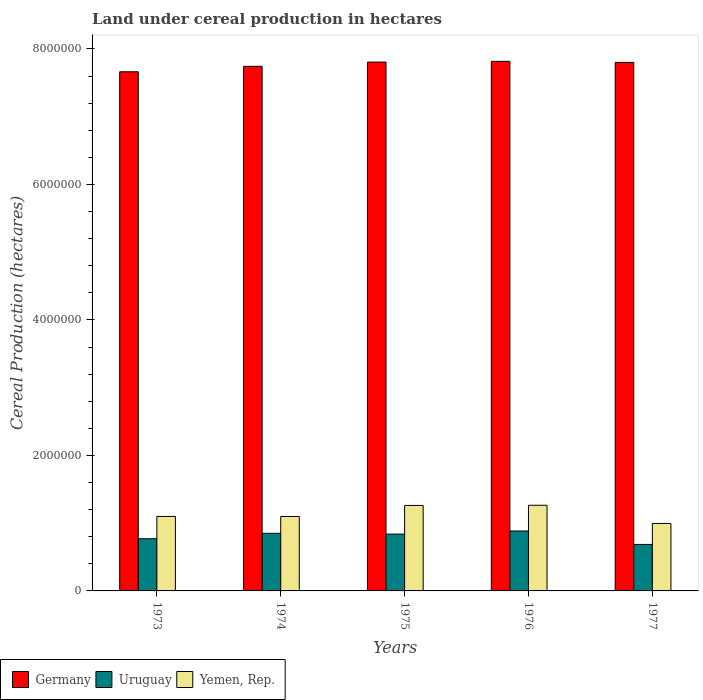How many different coloured bars are there?
Give a very brief answer. 3. Are the number of bars per tick equal to the number of legend labels?
Offer a terse response. Yes. Are the number of bars on each tick of the X-axis equal?
Provide a short and direct response. Yes. How many bars are there on the 4th tick from the left?
Offer a terse response. 3. What is the land under cereal production in Germany in 1974?
Provide a succinct answer. 7.74e+06. Across all years, what is the maximum land under cereal production in Yemen, Rep.?
Give a very brief answer. 1.26e+06. Across all years, what is the minimum land under cereal production in Uruguay?
Provide a short and direct response. 6.86e+05. In which year was the land under cereal production in Yemen, Rep. maximum?
Make the answer very short. 1976. What is the total land under cereal production in Germany in the graph?
Your answer should be very brief. 3.88e+07. What is the difference between the land under cereal production in Germany in 1973 and that in 1977?
Your answer should be compact. -1.38e+05. What is the difference between the land under cereal production in Yemen, Rep. in 1973 and the land under cereal production in Germany in 1974?
Provide a succinct answer. -6.64e+06. What is the average land under cereal production in Uruguay per year?
Offer a very short reply. 8.06e+05. In the year 1975, what is the difference between the land under cereal production in Yemen, Rep. and land under cereal production in Uruguay?
Make the answer very short. 4.23e+05. What is the ratio of the land under cereal production in Yemen, Rep. in 1974 to that in 1976?
Your response must be concise. 0.87. What is the difference between the highest and the second highest land under cereal production in Germany?
Your answer should be compact. 1.08e+04. What is the difference between the highest and the lowest land under cereal production in Yemen, Rep.?
Keep it short and to the point. 2.69e+05. In how many years, is the land under cereal production in Yemen, Rep. greater than the average land under cereal production in Yemen, Rep. taken over all years?
Make the answer very short. 2. Is the sum of the land under cereal production in Yemen, Rep. in 1975 and 1977 greater than the maximum land under cereal production in Germany across all years?
Provide a succinct answer. No. What does the 3rd bar from the left in 1976 represents?
Offer a terse response. Yemen, Rep. What does the 1st bar from the right in 1976 represents?
Keep it short and to the point. Yemen, Rep. Is it the case that in every year, the sum of the land under cereal production in Uruguay and land under cereal production in Yemen, Rep. is greater than the land under cereal production in Germany?
Offer a terse response. No. Are all the bars in the graph horizontal?
Your answer should be compact. No. How many years are there in the graph?
Offer a terse response. 5. What is the difference between two consecutive major ticks on the Y-axis?
Offer a very short reply. 2.00e+06. Are the values on the major ticks of Y-axis written in scientific E-notation?
Keep it short and to the point. No. What is the title of the graph?
Ensure brevity in your answer.  Land under cereal production in hectares. Does "Slovenia" appear as one of the legend labels in the graph?
Keep it short and to the point. No. What is the label or title of the Y-axis?
Your response must be concise. Cereal Production (hectares). What is the Cereal Production (hectares) in Germany in 1973?
Provide a succinct answer. 7.66e+06. What is the Cereal Production (hectares) in Uruguay in 1973?
Provide a short and direct response. 7.70e+05. What is the Cereal Production (hectares) in Yemen, Rep. in 1973?
Offer a very short reply. 1.10e+06. What is the Cereal Production (hectares) in Germany in 1974?
Offer a very short reply. 7.74e+06. What is the Cereal Production (hectares) of Uruguay in 1974?
Offer a very short reply. 8.50e+05. What is the Cereal Production (hectares) in Yemen, Rep. in 1974?
Provide a succinct answer. 1.10e+06. What is the Cereal Production (hectares) of Germany in 1975?
Offer a terse response. 7.81e+06. What is the Cereal Production (hectares) of Uruguay in 1975?
Your response must be concise. 8.39e+05. What is the Cereal Production (hectares) in Yemen, Rep. in 1975?
Your response must be concise. 1.26e+06. What is the Cereal Production (hectares) in Germany in 1976?
Make the answer very short. 7.82e+06. What is the Cereal Production (hectares) of Uruguay in 1976?
Keep it short and to the point. 8.84e+05. What is the Cereal Production (hectares) in Yemen, Rep. in 1976?
Make the answer very short. 1.26e+06. What is the Cereal Production (hectares) of Germany in 1977?
Your answer should be compact. 7.80e+06. What is the Cereal Production (hectares) in Uruguay in 1977?
Make the answer very short. 6.86e+05. What is the Cereal Production (hectares) of Yemen, Rep. in 1977?
Make the answer very short. 9.96e+05. Across all years, what is the maximum Cereal Production (hectares) in Germany?
Give a very brief answer. 7.82e+06. Across all years, what is the maximum Cereal Production (hectares) of Uruguay?
Your answer should be very brief. 8.84e+05. Across all years, what is the maximum Cereal Production (hectares) of Yemen, Rep.?
Make the answer very short. 1.26e+06. Across all years, what is the minimum Cereal Production (hectares) of Germany?
Your answer should be very brief. 7.66e+06. Across all years, what is the minimum Cereal Production (hectares) in Uruguay?
Offer a terse response. 6.86e+05. Across all years, what is the minimum Cereal Production (hectares) in Yemen, Rep.?
Make the answer very short. 9.96e+05. What is the total Cereal Production (hectares) in Germany in the graph?
Provide a succinct answer. 3.88e+07. What is the total Cereal Production (hectares) of Uruguay in the graph?
Keep it short and to the point. 4.03e+06. What is the total Cereal Production (hectares) in Yemen, Rep. in the graph?
Offer a very short reply. 5.72e+06. What is the difference between the Cereal Production (hectares) in Germany in 1973 and that in 1974?
Your response must be concise. -8.06e+04. What is the difference between the Cereal Production (hectares) of Uruguay in 1973 and that in 1974?
Provide a succinct answer. -8.00e+04. What is the difference between the Cereal Production (hectares) of Yemen, Rep. in 1973 and that in 1974?
Your response must be concise. 1048. What is the difference between the Cereal Production (hectares) of Germany in 1973 and that in 1975?
Your response must be concise. -1.43e+05. What is the difference between the Cereal Production (hectares) of Uruguay in 1973 and that in 1975?
Your answer should be very brief. -6.84e+04. What is the difference between the Cereal Production (hectares) in Yemen, Rep. in 1973 and that in 1975?
Ensure brevity in your answer.  -1.62e+05. What is the difference between the Cereal Production (hectares) in Germany in 1973 and that in 1976?
Your answer should be compact. -1.54e+05. What is the difference between the Cereal Production (hectares) in Uruguay in 1973 and that in 1976?
Provide a succinct answer. -1.14e+05. What is the difference between the Cereal Production (hectares) of Yemen, Rep. in 1973 and that in 1976?
Offer a terse response. -1.65e+05. What is the difference between the Cereal Production (hectares) in Germany in 1973 and that in 1977?
Ensure brevity in your answer.  -1.38e+05. What is the difference between the Cereal Production (hectares) in Uruguay in 1973 and that in 1977?
Give a very brief answer. 8.44e+04. What is the difference between the Cereal Production (hectares) of Yemen, Rep. in 1973 and that in 1977?
Offer a terse response. 1.04e+05. What is the difference between the Cereal Production (hectares) of Germany in 1974 and that in 1975?
Your answer should be compact. -6.24e+04. What is the difference between the Cereal Production (hectares) in Uruguay in 1974 and that in 1975?
Ensure brevity in your answer.  1.16e+04. What is the difference between the Cereal Production (hectares) of Yemen, Rep. in 1974 and that in 1975?
Offer a terse response. -1.63e+05. What is the difference between the Cereal Production (hectares) in Germany in 1974 and that in 1976?
Your answer should be compact. -7.32e+04. What is the difference between the Cereal Production (hectares) in Uruguay in 1974 and that in 1976?
Your response must be concise. -3.38e+04. What is the difference between the Cereal Production (hectares) of Yemen, Rep. in 1974 and that in 1976?
Offer a terse response. -1.66e+05. What is the difference between the Cereal Production (hectares) of Germany in 1974 and that in 1977?
Give a very brief answer. -5.75e+04. What is the difference between the Cereal Production (hectares) of Uruguay in 1974 and that in 1977?
Offer a terse response. 1.64e+05. What is the difference between the Cereal Production (hectares) in Yemen, Rep. in 1974 and that in 1977?
Give a very brief answer. 1.03e+05. What is the difference between the Cereal Production (hectares) in Germany in 1975 and that in 1976?
Ensure brevity in your answer.  -1.08e+04. What is the difference between the Cereal Production (hectares) of Uruguay in 1975 and that in 1976?
Provide a short and direct response. -4.54e+04. What is the difference between the Cereal Production (hectares) of Yemen, Rep. in 1975 and that in 1976?
Provide a short and direct response. -2667. What is the difference between the Cereal Production (hectares) in Germany in 1975 and that in 1977?
Give a very brief answer. 4952. What is the difference between the Cereal Production (hectares) in Uruguay in 1975 and that in 1977?
Make the answer very short. 1.53e+05. What is the difference between the Cereal Production (hectares) in Yemen, Rep. in 1975 and that in 1977?
Your response must be concise. 2.66e+05. What is the difference between the Cereal Production (hectares) of Germany in 1976 and that in 1977?
Make the answer very short. 1.58e+04. What is the difference between the Cereal Production (hectares) in Uruguay in 1976 and that in 1977?
Give a very brief answer. 1.98e+05. What is the difference between the Cereal Production (hectares) in Yemen, Rep. in 1976 and that in 1977?
Offer a terse response. 2.69e+05. What is the difference between the Cereal Production (hectares) of Germany in 1973 and the Cereal Production (hectares) of Uruguay in 1974?
Give a very brief answer. 6.81e+06. What is the difference between the Cereal Production (hectares) of Germany in 1973 and the Cereal Production (hectares) of Yemen, Rep. in 1974?
Your answer should be very brief. 6.56e+06. What is the difference between the Cereal Production (hectares) of Uruguay in 1973 and the Cereal Production (hectares) of Yemen, Rep. in 1974?
Your response must be concise. -3.28e+05. What is the difference between the Cereal Production (hectares) in Germany in 1973 and the Cereal Production (hectares) in Uruguay in 1975?
Give a very brief answer. 6.82e+06. What is the difference between the Cereal Production (hectares) in Germany in 1973 and the Cereal Production (hectares) in Yemen, Rep. in 1975?
Provide a succinct answer. 6.40e+06. What is the difference between the Cereal Production (hectares) of Uruguay in 1973 and the Cereal Production (hectares) of Yemen, Rep. in 1975?
Your response must be concise. -4.91e+05. What is the difference between the Cereal Production (hectares) in Germany in 1973 and the Cereal Production (hectares) in Uruguay in 1976?
Offer a very short reply. 6.78e+06. What is the difference between the Cereal Production (hectares) of Germany in 1973 and the Cereal Production (hectares) of Yemen, Rep. in 1976?
Provide a short and direct response. 6.40e+06. What is the difference between the Cereal Production (hectares) of Uruguay in 1973 and the Cereal Production (hectares) of Yemen, Rep. in 1976?
Give a very brief answer. -4.94e+05. What is the difference between the Cereal Production (hectares) of Germany in 1973 and the Cereal Production (hectares) of Uruguay in 1977?
Your response must be concise. 6.98e+06. What is the difference between the Cereal Production (hectares) in Germany in 1973 and the Cereal Production (hectares) in Yemen, Rep. in 1977?
Give a very brief answer. 6.67e+06. What is the difference between the Cereal Production (hectares) of Uruguay in 1973 and the Cereal Production (hectares) of Yemen, Rep. in 1977?
Give a very brief answer. -2.25e+05. What is the difference between the Cereal Production (hectares) of Germany in 1974 and the Cereal Production (hectares) of Uruguay in 1975?
Your response must be concise. 6.90e+06. What is the difference between the Cereal Production (hectares) in Germany in 1974 and the Cereal Production (hectares) in Yemen, Rep. in 1975?
Ensure brevity in your answer.  6.48e+06. What is the difference between the Cereal Production (hectares) in Uruguay in 1974 and the Cereal Production (hectares) in Yemen, Rep. in 1975?
Your answer should be very brief. -4.11e+05. What is the difference between the Cereal Production (hectares) in Germany in 1974 and the Cereal Production (hectares) in Uruguay in 1976?
Keep it short and to the point. 6.86e+06. What is the difference between the Cereal Production (hectares) of Germany in 1974 and the Cereal Production (hectares) of Yemen, Rep. in 1976?
Your response must be concise. 6.48e+06. What is the difference between the Cereal Production (hectares) of Uruguay in 1974 and the Cereal Production (hectares) of Yemen, Rep. in 1976?
Give a very brief answer. -4.14e+05. What is the difference between the Cereal Production (hectares) of Germany in 1974 and the Cereal Production (hectares) of Uruguay in 1977?
Your answer should be very brief. 7.06e+06. What is the difference between the Cereal Production (hectares) of Germany in 1974 and the Cereal Production (hectares) of Yemen, Rep. in 1977?
Give a very brief answer. 6.75e+06. What is the difference between the Cereal Production (hectares) of Uruguay in 1974 and the Cereal Production (hectares) of Yemen, Rep. in 1977?
Your answer should be very brief. -1.45e+05. What is the difference between the Cereal Production (hectares) in Germany in 1975 and the Cereal Production (hectares) in Uruguay in 1976?
Your response must be concise. 6.92e+06. What is the difference between the Cereal Production (hectares) in Germany in 1975 and the Cereal Production (hectares) in Yemen, Rep. in 1976?
Provide a succinct answer. 6.54e+06. What is the difference between the Cereal Production (hectares) of Uruguay in 1975 and the Cereal Production (hectares) of Yemen, Rep. in 1976?
Your answer should be very brief. -4.26e+05. What is the difference between the Cereal Production (hectares) in Germany in 1975 and the Cereal Production (hectares) in Uruguay in 1977?
Provide a short and direct response. 7.12e+06. What is the difference between the Cereal Production (hectares) in Germany in 1975 and the Cereal Production (hectares) in Yemen, Rep. in 1977?
Your answer should be very brief. 6.81e+06. What is the difference between the Cereal Production (hectares) in Uruguay in 1975 and the Cereal Production (hectares) in Yemen, Rep. in 1977?
Offer a terse response. -1.57e+05. What is the difference between the Cereal Production (hectares) of Germany in 1976 and the Cereal Production (hectares) of Uruguay in 1977?
Your answer should be very brief. 7.13e+06. What is the difference between the Cereal Production (hectares) of Germany in 1976 and the Cereal Production (hectares) of Yemen, Rep. in 1977?
Your response must be concise. 6.82e+06. What is the difference between the Cereal Production (hectares) of Uruguay in 1976 and the Cereal Production (hectares) of Yemen, Rep. in 1977?
Your response must be concise. -1.11e+05. What is the average Cereal Production (hectares) in Germany per year?
Keep it short and to the point. 7.77e+06. What is the average Cereal Production (hectares) of Uruguay per year?
Your answer should be very brief. 8.06e+05. What is the average Cereal Production (hectares) in Yemen, Rep. per year?
Your answer should be compact. 1.14e+06. In the year 1973, what is the difference between the Cereal Production (hectares) of Germany and Cereal Production (hectares) of Uruguay?
Your answer should be very brief. 6.89e+06. In the year 1973, what is the difference between the Cereal Production (hectares) in Germany and Cereal Production (hectares) in Yemen, Rep.?
Offer a terse response. 6.56e+06. In the year 1973, what is the difference between the Cereal Production (hectares) of Uruguay and Cereal Production (hectares) of Yemen, Rep.?
Provide a succinct answer. -3.29e+05. In the year 1974, what is the difference between the Cereal Production (hectares) in Germany and Cereal Production (hectares) in Uruguay?
Your response must be concise. 6.89e+06. In the year 1974, what is the difference between the Cereal Production (hectares) in Germany and Cereal Production (hectares) in Yemen, Rep.?
Your answer should be very brief. 6.64e+06. In the year 1974, what is the difference between the Cereal Production (hectares) of Uruguay and Cereal Production (hectares) of Yemen, Rep.?
Provide a short and direct response. -2.48e+05. In the year 1975, what is the difference between the Cereal Production (hectares) of Germany and Cereal Production (hectares) of Uruguay?
Offer a very short reply. 6.97e+06. In the year 1975, what is the difference between the Cereal Production (hectares) in Germany and Cereal Production (hectares) in Yemen, Rep.?
Your answer should be very brief. 6.54e+06. In the year 1975, what is the difference between the Cereal Production (hectares) of Uruguay and Cereal Production (hectares) of Yemen, Rep.?
Ensure brevity in your answer.  -4.23e+05. In the year 1976, what is the difference between the Cereal Production (hectares) of Germany and Cereal Production (hectares) of Uruguay?
Ensure brevity in your answer.  6.93e+06. In the year 1976, what is the difference between the Cereal Production (hectares) of Germany and Cereal Production (hectares) of Yemen, Rep.?
Ensure brevity in your answer.  6.55e+06. In the year 1976, what is the difference between the Cereal Production (hectares) of Uruguay and Cereal Production (hectares) of Yemen, Rep.?
Your answer should be very brief. -3.80e+05. In the year 1977, what is the difference between the Cereal Production (hectares) of Germany and Cereal Production (hectares) of Uruguay?
Keep it short and to the point. 7.11e+06. In the year 1977, what is the difference between the Cereal Production (hectares) of Germany and Cereal Production (hectares) of Yemen, Rep.?
Provide a succinct answer. 6.80e+06. In the year 1977, what is the difference between the Cereal Production (hectares) in Uruguay and Cereal Production (hectares) in Yemen, Rep.?
Offer a terse response. -3.10e+05. What is the ratio of the Cereal Production (hectares) of Uruguay in 1973 to that in 1974?
Offer a terse response. 0.91. What is the ratio of the Cereal Production (hectares) of Germany in 1973 to that in 1975?
Ensure brevity in your answer.  0.98. What is the ratio of the Cereal Production (hectares) of Uruguay in 1973 to that in 1975?
Ensure brevity in your answer.  0.92. What is the ratio of the Cereal Production (hectares) in Yemen, Rep. in 1973 to that in 1975?
Give a very brief answer. 0.87. What is the ratio of the Cereal Production (hectares) of Germany in 1973 to that in 1976?
Provide a short and direct response. 0.98. What is the ratio of the Cereal Production (hectares) in Uruguay in 1973 to that in 1976?
Ensure brevity in your answer.  0.87. What is the ratio of the Cereal Production (hectares) in Yemen, Rep. in 1973 to that in 1976?
Offer a terse response. 0.87. What is the ratio of the Cereal Production (hectares) of Germany in 1973 to that in 1977?
Keep it short and to the point. 0.98. What is the ratio of the Cereal Production (hectares) of Uruguay in 1973 to that in 1977?
Offer a very short reply. 1.12. What is the ratio of the Cereal Production (hectares) in Yemen, Rep. in 1973 to that in 1977?
Your answer should be compact. 1.1. What is the ratio of the Cereal Production (hectares) in Germany in 1974 to that in 1975?
Your answer should be very brief. 0.99. What is the ratio of the Cereal Production (hectares) of Uruguay in 1974 to that in 1975?
Make the answer very short. 1.01. What is the ratio of the Cereal Production (hectares) in Yemen, Rep. in 1974 to that in 1975?
Your answer should be very brief. 0.87. What is the ratio of the Cereal Production (hectares) of Germany in 1974 to that in 1976?
Your response must be concise. 0.99. What is the ratio of the Cereal Production (hectares) of Uruguay in 1974 to that in 1976?
Provide a succinct answer. 0.96. What is the ratio of the Cereal Production (hectares) of Yemen, Rep. in 1974 to that in 1976?
Offer a terse response. 0.87. What is the ratio of the Cereal Production (hectares) in Uruguay in 1974 to that in 1977?
Ensure brevity in your answer.  1.24. What is the ratio of the Cereal Production (hectares) of Yemen, Rep. in 1974 to that in 1977?
Ensure brevity in your answer.  1.1. What is the ratio of the Cereal Production (hectares) in Uruguay in 1975 to that in 1976?
Provide a short and direct response. 0.95. What is the ratio of the Cereal Production (hectares) in Yemen, Rep. in 1975 to that in 1976?
Give a very brief answer. 1. What is the ratio of the Cereal Production (hectares) in Uruguay in 1975 to that in 1977?
Provide a short and direct response. 1.22. What is the ratio of the Cereal Production (hectares) of Yemen, Rep. in 1975 to that in 1977?
Your response must be concise. 1.27. What is the ratio of the Cereal Production (hectares) of Germany in 1976 to that in 1977?
Provide a succinct answer. 1. What is the ratio of the Cereal Production (hectares) in Uruguay in 1976 to that in 1977?
Your answer should be compact. 1.29. What is the ratio of the Cereal Production (hectares) of Yemen, Rep. in 1976 to that in 1977?
Offer a very short reply. 1.27. What is the difference between the highest and the second highest Cereal Production (hectares) in Germany?
Offer a very short reply. 1.08e+04. What is the difference between the highest and the second highest Cereal Production (hectares) in Uruguay?
Ensure brevity in your answer.  3.38e+04. What is the difference between the highest and the second highest Cereal Production (hectares) of Yemen, Rep.?
Keep it short and to the point. 2667. What is the difference between the highest and the lowest Cereal Production (hectares) of Germany?
Provide a short and direct response. 1.54e+05. What is the difference between the highest and the lowest Cereal Production (hectares) in Uruguay?
Your answer should be very brief. 1.98e+05. What is the difference between the highest and the lowest Cereal Production (hectares) of Yemen, Rep.?
Keep it short and to the point. 2.69e+05. 